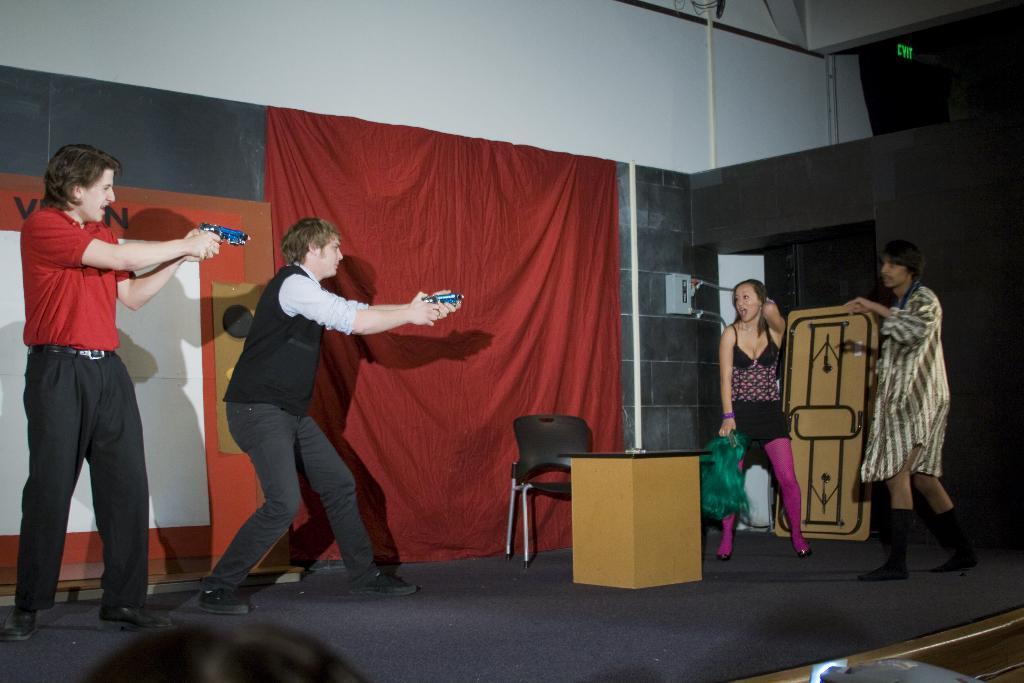Describe this image in one or two sentences. This is a picture taken during a stage performance, on the stage there are four people acting. In the center of the stage there is a chair and desk. In the background there is a red color curtain and a wall painted white. On the right there is a black colored curtain. 